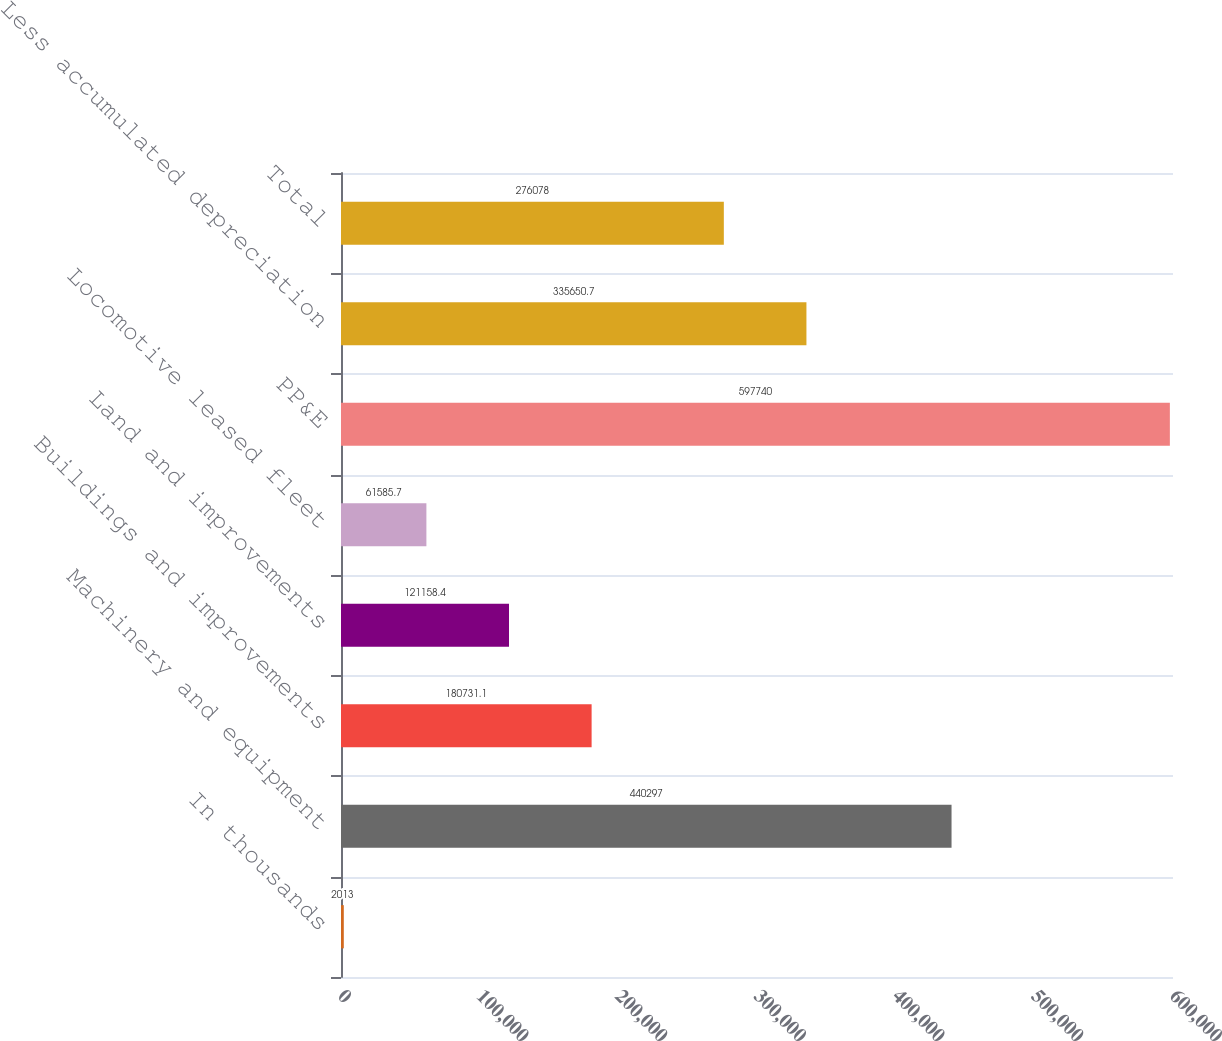Convert chart. <chart><loc_0><loc_0><loc_500><loc_500><bar_chart><fcel>In thousands<fcel>Machinery and equipment<fcel>Buildings and improvements<fcel>Land and improvements<fcel>Locomotive leased fleet<fcel>PP&E<fcel>Less accumulated depreciation<fcel>Total<nl><fcel>2013<fcel>440297<fcel>180731<fcel>121158<fcel>61585.7<fcel>597740<fcel>335651<fcel>276078<nl></chart> 